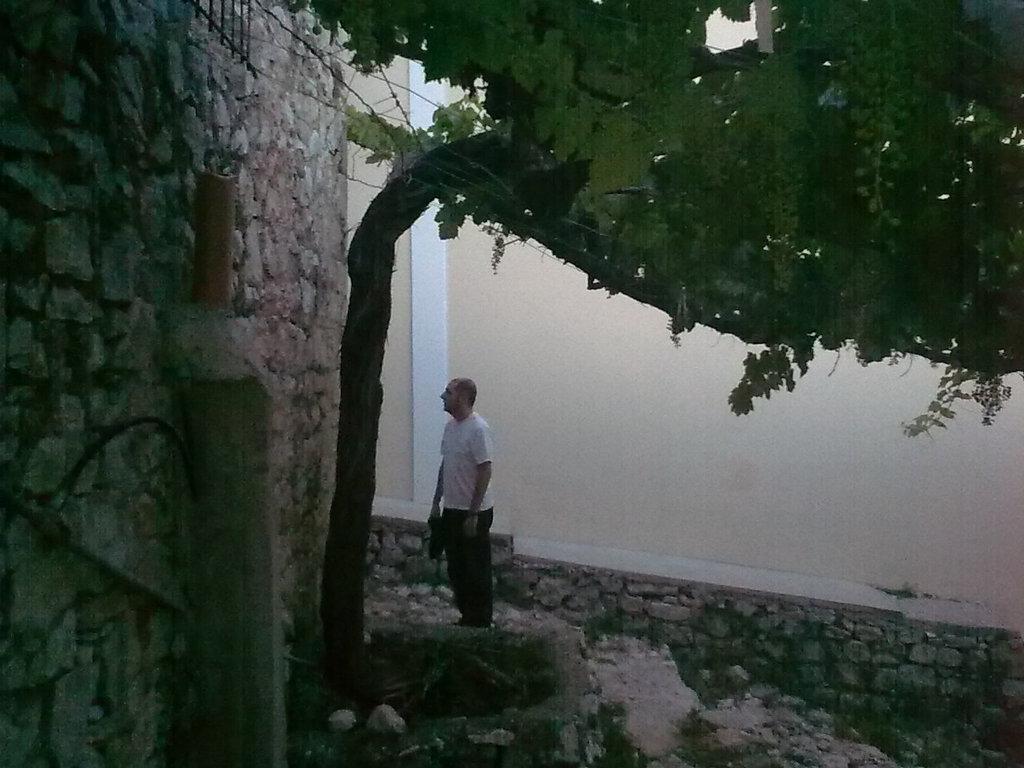Describe this image in one or two sentences. In the image there is a man and on the left side of the man there is a wall and in front of the wall there is a tree and there is a wall behind the man. 